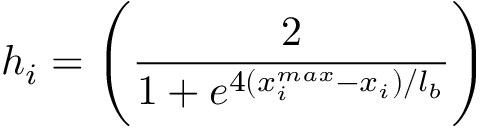Convert formula to latex. <formula><loc_0><loc_0><loc_500><loc_500>h _ { i } = \left ( \frac { 2 } { 1 + e ^ { 4 ( { x _ { i } ^ { \max } - x _ { i } } ) / l _ { b } } } \right )</formula> 